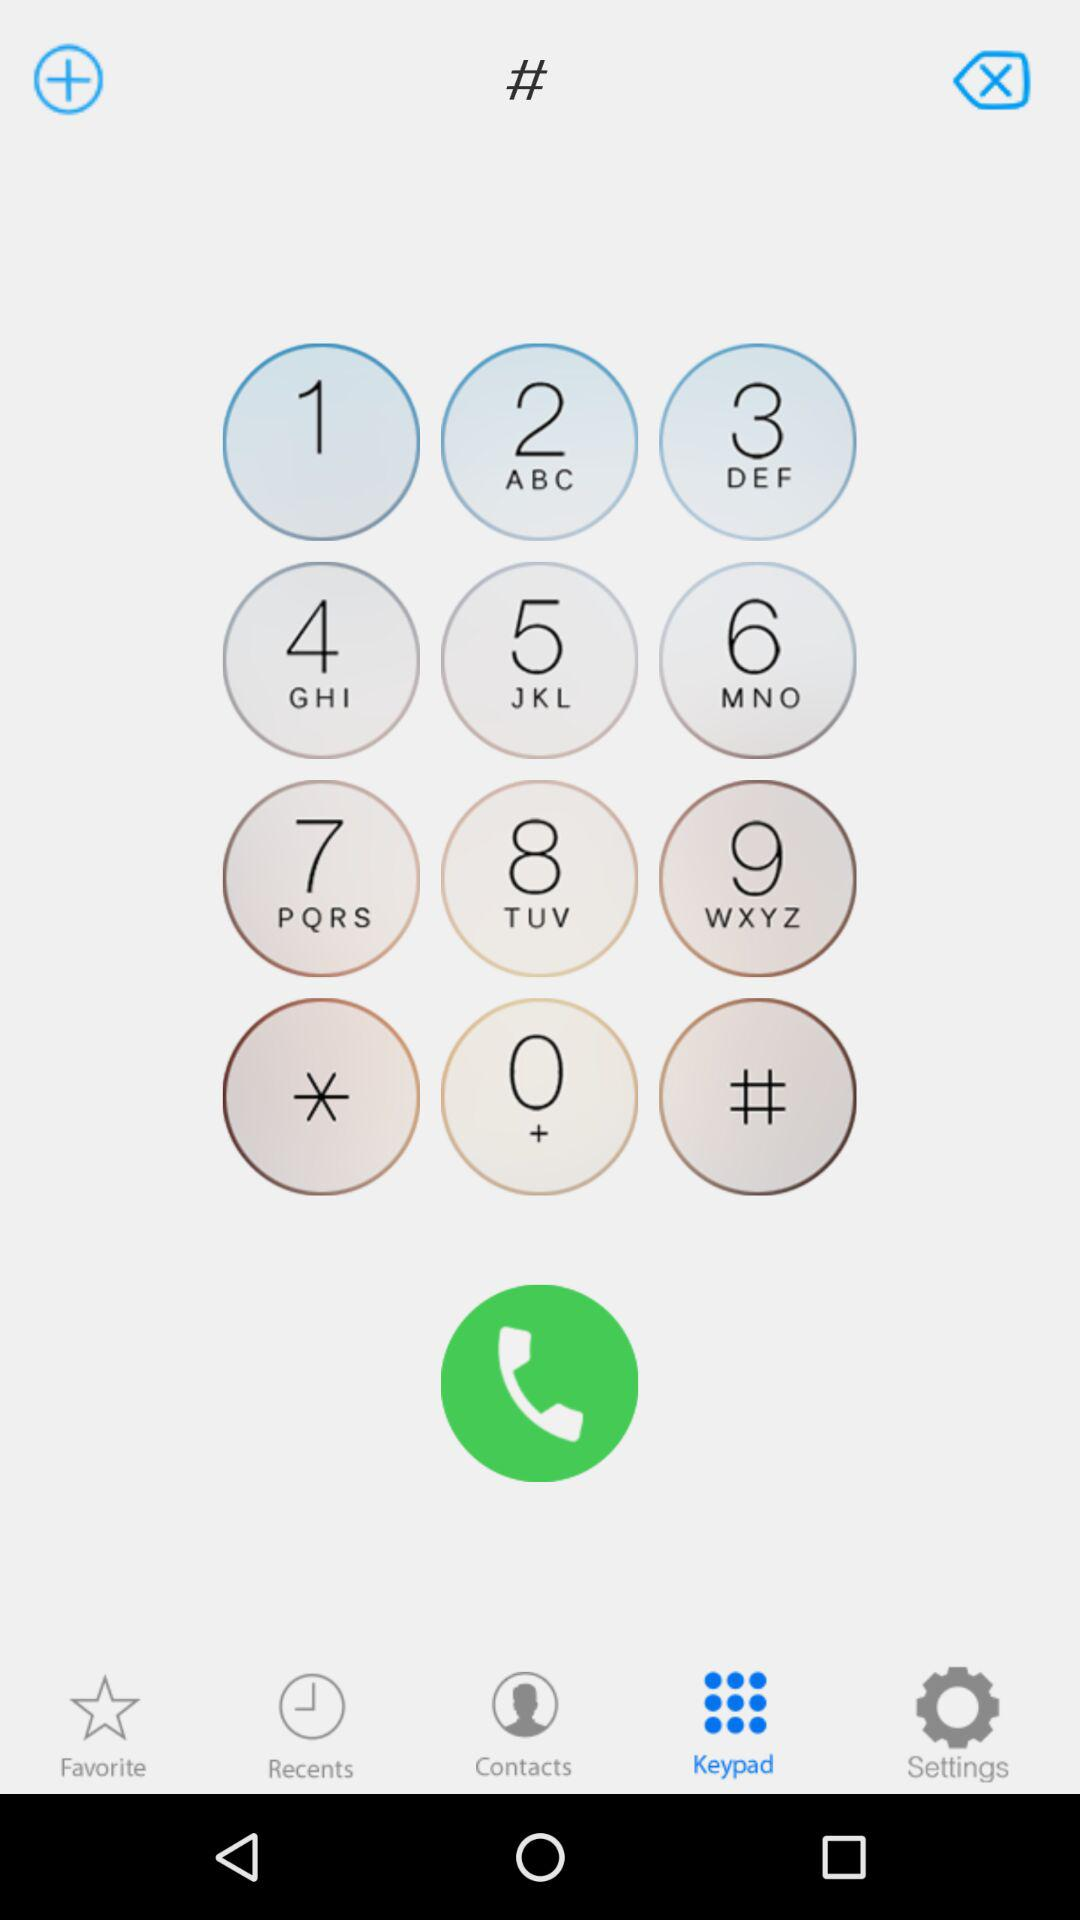Which alphabets are mentioned in number 7? The mentioned alphabets in number 7 are P, Q, R and S. 